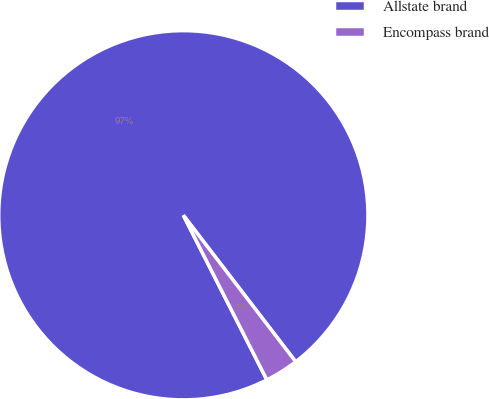Convert chart to OTSL. <chart><loc_0><loc_0><loc_500><loc_500><pie_chart><fcel>Allstate brand<fcel>Encompass brand<nl><fcel>97.06%<fcel>2.94%<nl></chart> 